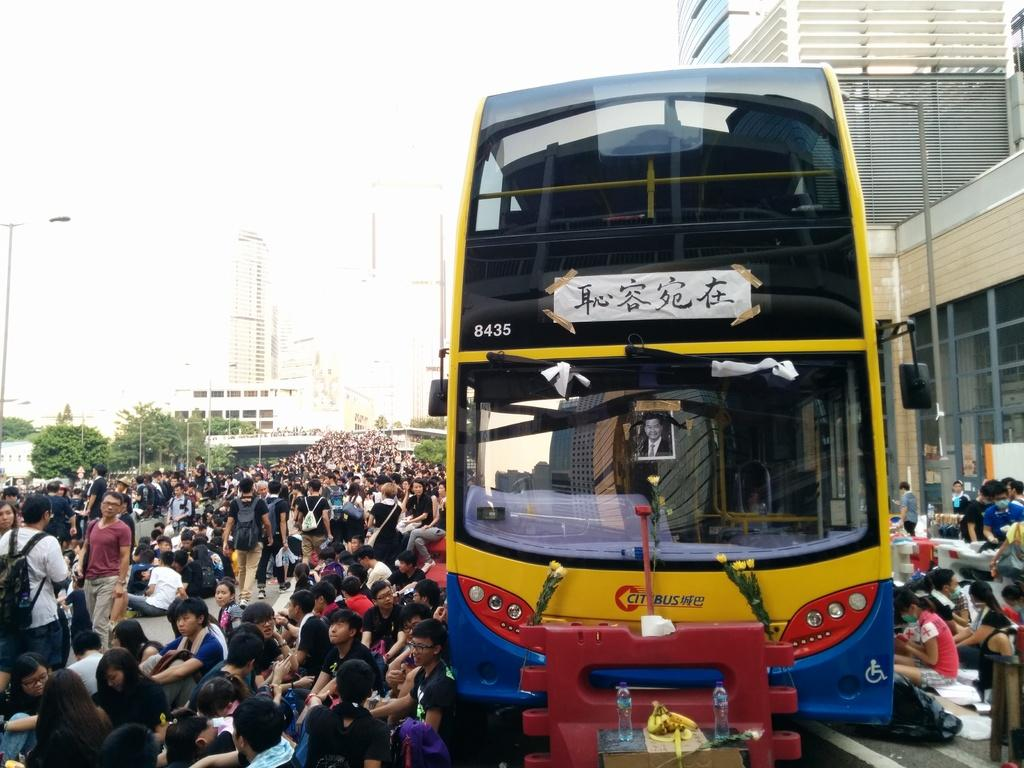What is the main subject of the image? The main subject of the image is a bus. What else can be seen on the road in the image? There are persons on the road in the image. What is visible in the background of the image? There are buildings, poles, trees, and the sky visible in the background of the image. What type of food is being served on the bus in the image? There is no food visible in the image, and the bus does not appear to be serving any food. 